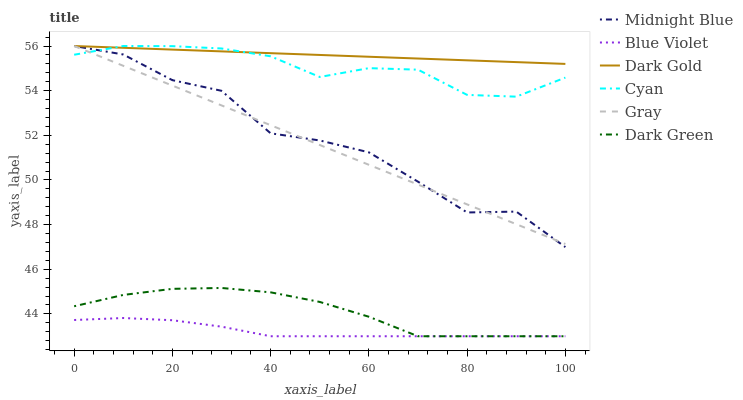Does Blue Violet have the minimum area under the curve?
Answer yes or no. Yes. Does Dark Gold have the maximum area under the curve?
Answer yes or no. Yes. Does Midnight Blue have the minimum area under the curve?
Answer yes or no. No. Does Midnight Blue have the maximum area under the curve?
Answer yes or no. No. Is Gray the smoothest?
Answer yes or no. Yes. Is Midnight Blue the roughest?
Answer yes or no. Yes. Is Dark Gold the smoothest?
Answer yes or no. No. Is Dark Gold the roughest?
Answer yes or no. No. Does Midnight Blue have the lowest value?
Answer yes or no. No. Does Cyan have the highest value?
Answer yes or no. Yes. Does Blue Violet have the highest value?
Answer yes or no. No. Is Dark Green less than Cyan?
Answer yes or no. Yes. Is Gray greater than Dark Green?
Answer yes or no. Yes. Does Cyan intersect Dark Gold?
Answer yes or no. Yes. Is Cyan less than Dark Gold?
Answer yes or no. No. Is Cyan greater than Dark Gold?
Answer yes or no. No. Does Dark Green intersect Cyan?
Answer yes or no. No. 